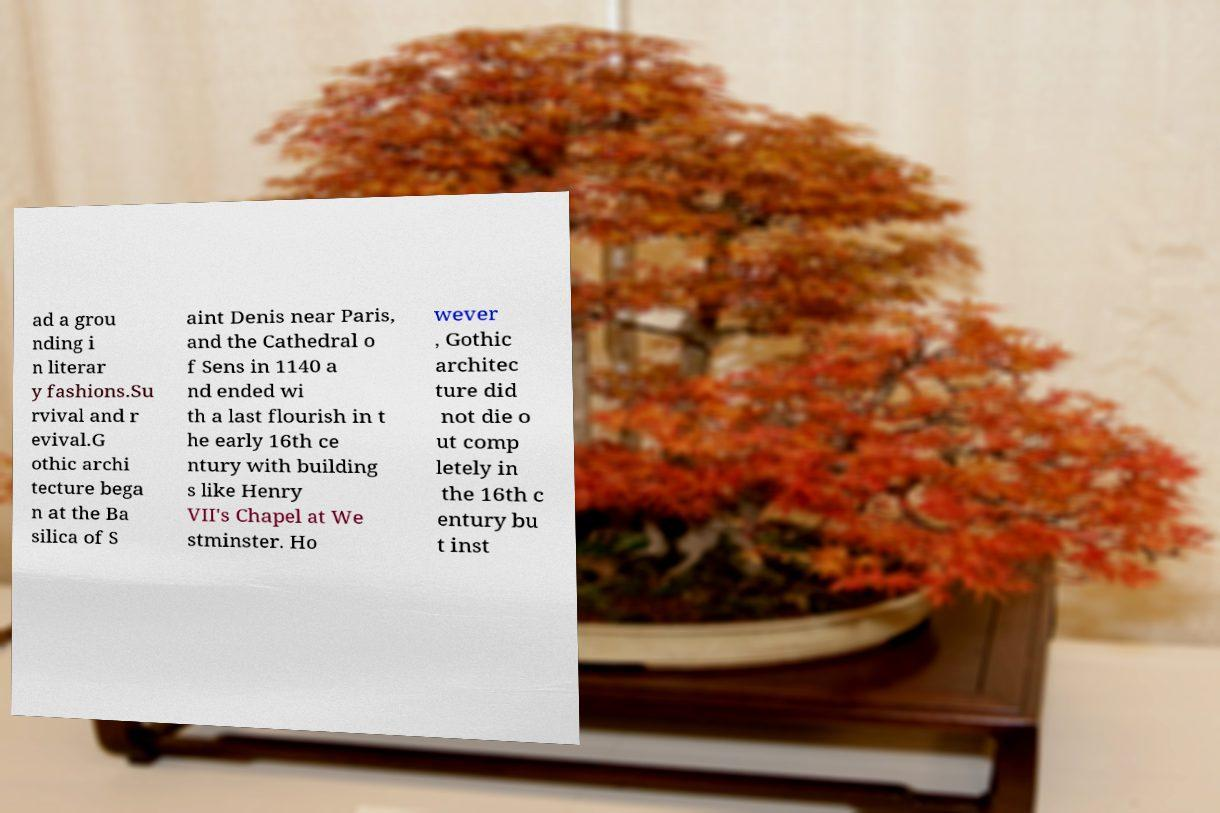I need the written content from this picture converted into text. Can you do that? ad a grou nding i n literar y fashions.Su rvival and r evival.G othic archi tecture bega n at the Ba silica of S aint Denis near Paris, and the Cathedral o f Sens in 1140 a nd ended wi th a last flourish in t he early 16th ce ntury with building s like Henry VII's Chapel at We stminster. Ho wever , Gothic architec ture did not die o ut comp letely in the 16th c entury bu t inst 